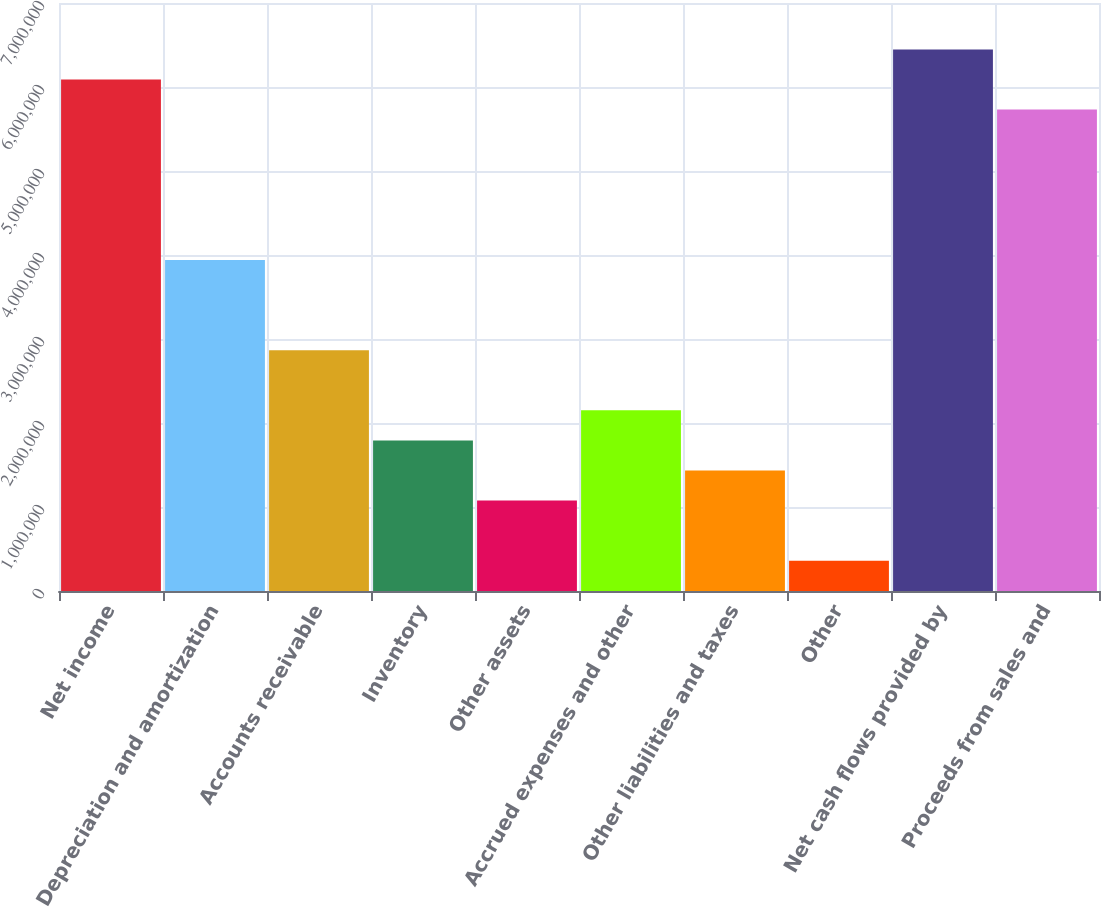Convert chart. <chart><loc_0><loc_0><loc_500><loc_500><bar_chart><fcel>Net income<fcel>Depreciation and amortization<fcel>Accounts receivable<fcel>Inventory<fcel>Other assets<fcel>Accrued expenses and other<fcel>Other liabilities and taxes<fcel>Other<fcel>Net cash flows provided by<fcel>Proceeds from sales and<nl><fcel>6.08948e+06<fcel>3.9412e+06<fcel>2.86705e+06<fcel>1.79291e+06<fcel>1.07682e+06<fcel>2.15096e+06<fcel>1.43486e+06<fcel>360722<fcel>6.44753e+06<fcel>5.73144e+06<nl></chart> 